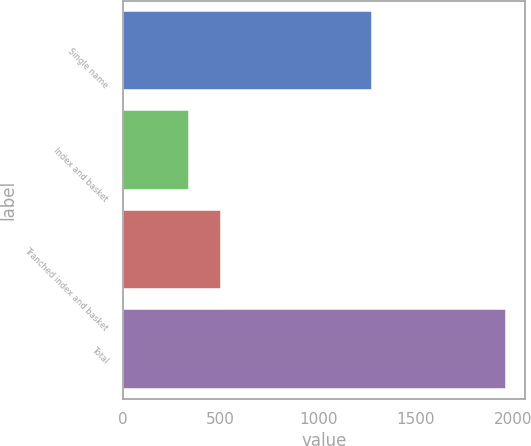Convert chart to OTSL. <chart><loc_0><loc_0><loc_500><loc_500><bar_chart><fcel>Single name<fcel>Index and basket<fcel>Tranched index and basket<fcel>Total<nl><fcel>1277<fcel>341<fcel>502.9<fcel>1960<nl></chart> 